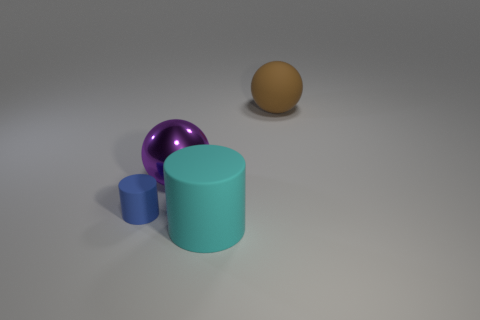There is a rubber thing that is behind the tiny blue object; does it have the same shape as the large rubber object in front of the large metallic sphere?
Your response must be concise. No. Are there any tiny blue cylinders made of the same material as the brown ball?
Offer a terse response. Yes. What is the color of the ball that is right of the sphere that is in front of the object behind the big purple metallic thing?
Your answer should be compact. Brown. Is the ball that is in front of the brown rubber object made of the same material as the large object to the right of the large cyan matte thing?
Your answer should be very brief. No. There is a large rubber object that is to the left of the large brown rubber sphere; what is its shape?
Keep it short and to the point. Cylinder. How many things are large brown balls or big matte objects that are behind the large cyan rubber thing?
Ensure brevity in your answer.  1. Does the tiny cylinder have the same material as the large cylinder?
Offer a very short reply. Yes. Are there an equal number of spheres in front of the big purple shiny object and large cyan objects that are to the right of the large cylinder?
Your answer should be very brief. Yes. What number of small blue things are in front of the large cyan object?
Make the answer very short. 0. What number of things are either metallic things or large red shiny cubes?
Make the answer very short. 1. 